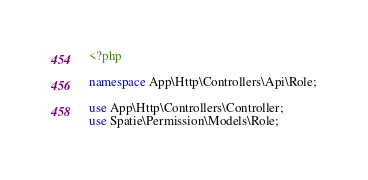Convert code to text. <code><loc_0><loc_0><loc_500><loc_500><_PHP_><?php

namespace App\Http\Controllers\Api\Role;

use App\Http\Controllers\Controller;
use Spatie\Permission\Models\Role;</code> 